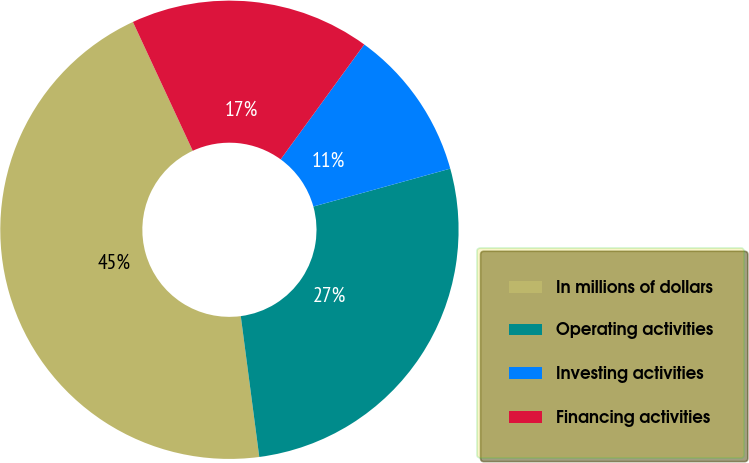Convert chart. <chart><loc_0><loc_0><loc_500><loc_500><pie_chart><fcel>In millions of dollars<fcel>Operating activities<fcel>Investing activities<fcel>Financing activities<nl><fcel>45.16%<fcel>27.22%<fcel>10.69%<fcel>16.93%<nl></chart> 